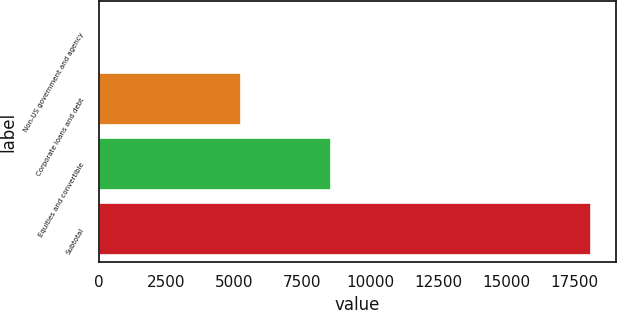Convert chart. <chart><loc_0><loc_0><loc_500><loc_500><bar_chart><fcel>Non-US government and agency<fcel>Corporate loans and debt<fcel>Equities and convertible<fcel>Subtotal<nl><fcel>12<fcel>5242<fcel>8549<fcel>18131<nl></chart> 